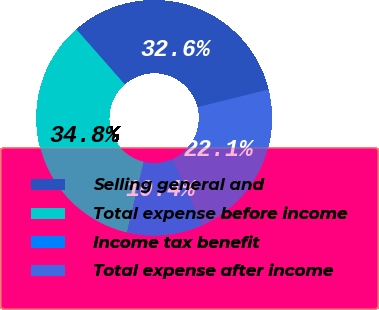Convert chart. <chart><loc_0><loc_0><loc_500><loc_500><pie_chart><fcel>Selling general and<fcel>Total expense before income<fcel>Income tax benefit<fcel>Total expense after income<nl><fcel>32.6%<fcel>34.81%<fcel>10.45%<fcel>22.14%<nl></chart> 